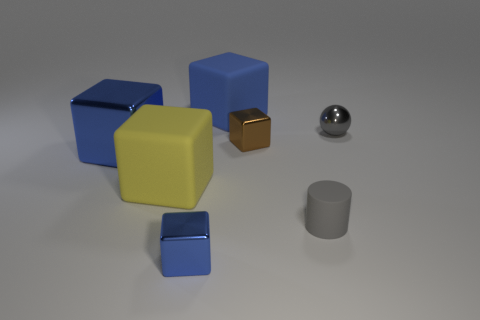Subtract all blue blocks. How many were subtracted if there are1blue blocks left? 2 Add 2 purple cylinders. How many objects exist? 9 Subtract all blue rubber cubes. How many cubes are left? 4 Subtract all yellow blocks. How many blocks are left? 4 Subtract all balls. How many objects are left? 6 Subtract 0 gray blocks. How many objects are left? 7 Subtract 2 cubes. How many cubes are left? 3 Subtract all blue spheres. Subtract all purple cylinders. How many spheres are left? 1 Subtract all red blocks. How many purple spheres are left? 0 Subtract all large purple rubber spheres. Subtract all small matte cylinders. How many objects are left? 6 